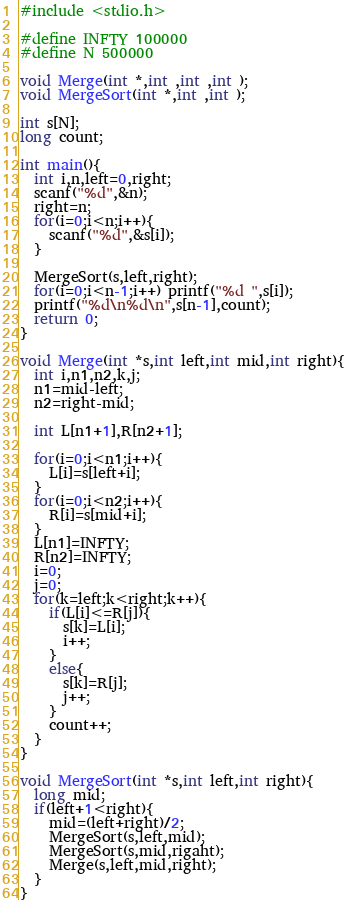Convert code to text. <code><loc_0><loc_0><loc_500><loc_500><_C_>#include <stdio.h>

#define INFTY 100000
#define N 500000

void Merge(int *,int ,int ,int );
void MergeSort(int *,int ,int );

int s[N];
long count;

int main(){
  int i,n,left=0,right;
  scanf("%d",&n);
  right=n;
  for(i=0;i<n;i++){
    scanf("%d",&s[i]);
  }
  
  MergeSort(s,left,right);
  for(i=0;i<n-1;i++) printf("%d ",s[i]);
  printf("%d\n%d\n",s[n-1],count);
  return 0;
}

void Merge(int *s,int left,int mid,int right){
  int i,n1,n2,k,j;
  n1=mid-left;
  n2=right-mid;
  
  int L[n1+1],R[n2+1];
  
  for(i=0;i<n1;i++){
    L[i]=s[left+i];
  }
  for(i=0;i<n2;i++){
    R[i]=s[mid+i];
  }
  L[n1]=INFTY;
  R[n2]=INFTY;
  i=0;
  j=0;
  for(k=left;k<right;k++){
    if(L[i]<=R[j]){
      s[k]=L[i];
      i++;
    }
    else{
      s[k]=R[j];
      j++;
    }
    count++;
  }
}

void MergeSort(int *s,int left,int right){
  long mid;
  if(left+1<right){
    mid=(left+right)/2;
    MergeSort(s,left,mid);
    MergeSort(s,mid,rigaht);
    Merge(s,left,mid,right);
  }
}</code> 